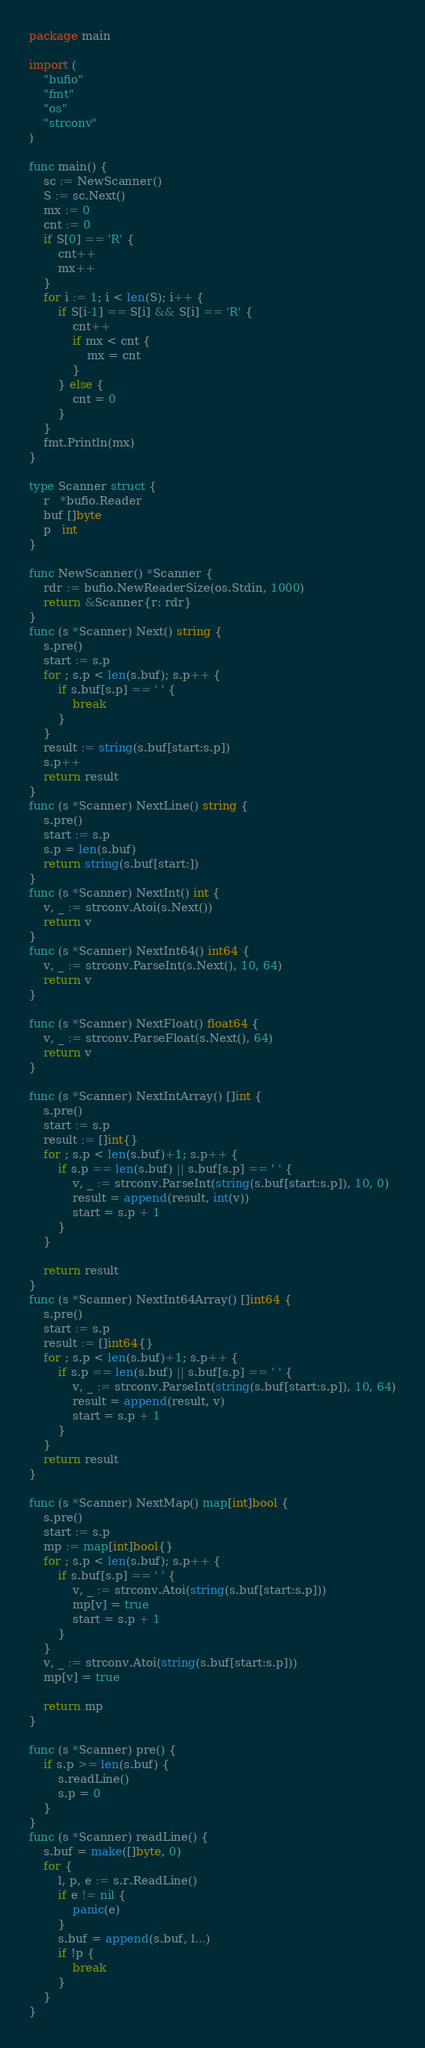Convert code to text. <code><loc_0><loc_0><loc_500><loc_500><_Go_>package main

import (
	"bufio"
	"fmt"
	"os"
	"strconv"
)

func main() {
	sc := NewScanner()
	S := sc.Next()
	mx := 0
	cnt := 0
	if S[0] == 'R' {
		cnt++
		mx++
	}
	for i := 1; i < len(S); i++ {
		if S[i-1] == S[i] && S[i] == 'R' {
			cnt++
			if mx < cnt {
				mx = cnt
			}
		} else {
			cnt = 0
		}
	}
	fmt.Println(mx)
}

type Scanner struct {
	r   *bufio.Reader
	buf []byte
	p   int
}

func NewScanner() *Scanner {
	rdr := bufio.NewReaderSize(os.Stdin, 1000)
	return &Scanner{r: rdr}
}
func (s *Scanner) Next() string {
	s.pre()
	start := s.p
	for ; s.p < len(s.buf); s.p++ {
		if s.buf[s.p] == ' ' {
			break
		}
	}
	result := string(s.buf[start:s.p])
	s.p++
	return result
}
func (s *Scanner) NextLine() string {
	s.pre()
	start := s.p
	s.p = len(s.buf)
	return string(s.buf[start:])
}
func (s *Scanner) NextInt() int {
	v, _ := strconv.Atoi(s.Next())
	return v
}
func (s *Scanner) NextInt64() int64 {
	v, _ := strconv.ParseInt(s.Next(), 10, 64)
	return v
}

func (s *Scanner) NextFloat() float64 {
	v, _ := strconv.ParseFloat(s.Next(), 64)
	return v
}

func (s *Scanner) NextIntArray() []int {
	s.pre()
	start := s.p
	result := []int{}
	for ; s.p < len(s.buf)+1; s.p++ {
		if s.p == len(s.buf) || s.buf[s.p] == ' ' {
			v, _ := strconv.ParseInt(string(s.buf[start:s.p]), 10, 0)
			result = append(result, int(v))
			start = s.p + 1
		}
	}

	return result
}
func (s *Scanner) NextInt64Array() []int64 {
	s.pre()
	start := s.p
	result := []int64{}
	for ; s.p < len(s.buf)+1; s.p++ {
		if s.p == len(s.buf) || s.buf[s.p] == ' ' {
			v, _ := strconv.ParseInt(string(s.buf[start:s.p]), 10, 64)
			result = append(result, v)
			start = s.p + 1
		}
	}
	return result
}

func (s *Scanner) NextMap() map[int]bool {
	s.pre()
	start := s.p
	mp := map[int]bool{}
	for ; s.p < len(s.buf); s.p++ {
		if s.buf[s.p] == ' ' {
			v, _ := strconv.Atoi(string(s.buf[start:s.p]))
			mp[v] = true
			start = s.p + 1
		}
	}
	v, _ := strconv.Atoi(string(s.buf[start:s.p]))
	mp[v] = true

	return mp
}

func (s *Scanner) pre() {
	if s.p >= len(s.buf) {
		s.readLine()
		s.p = 0
	}
}
func (s *Scanner) readLine() {
	s.buf = make([]byte, 0)
	for {
		l, p, e := s.r.ReadLine()
		if e != nil {
			panic(e)
		}
		s.buf = append(s.buf, l...)
		if !p {
			break
		}
	}
}
</code> 